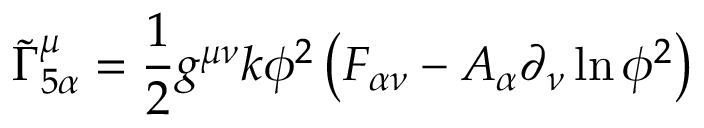Convert formula to latex. <formula><loc_0><loc_0><loc_500><loc_500>{ \widetilde { \Gamma } } _ { 5 \alpha } ^ { \mu } = { \frac { 1 } { 2 } } g ^ { \mu \nu } k \phi ^ { 2 } \left ( F _ { \alpha \nu } - A _ { \alpha } \partial _ { \nu } \ln \phi ^ { 2 } \right )</formula> 